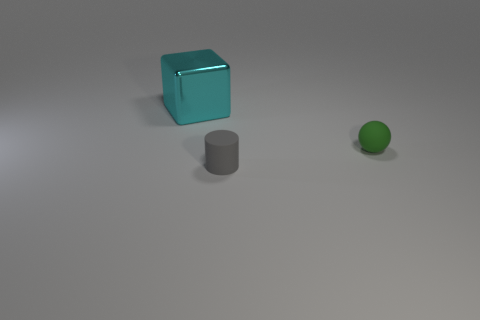Subtract 1 balls. How many balls are left? 0 Add 2 yellow rubber cylinders. How many objects exist? 5 Subtract all yellow spheres. How many purple cubes are left? 0 Subtract all blocks. How many objects are left? 2 Subtract all green objects. Subtract all matte things. How many objects are left? 0 Add 3 small gray cylinders. How many small gray cylinders are left? 4 Add 3 large cyan things. How many large cyan things exist? 4 Subtract 0 red balls. How many objects are left? 3 